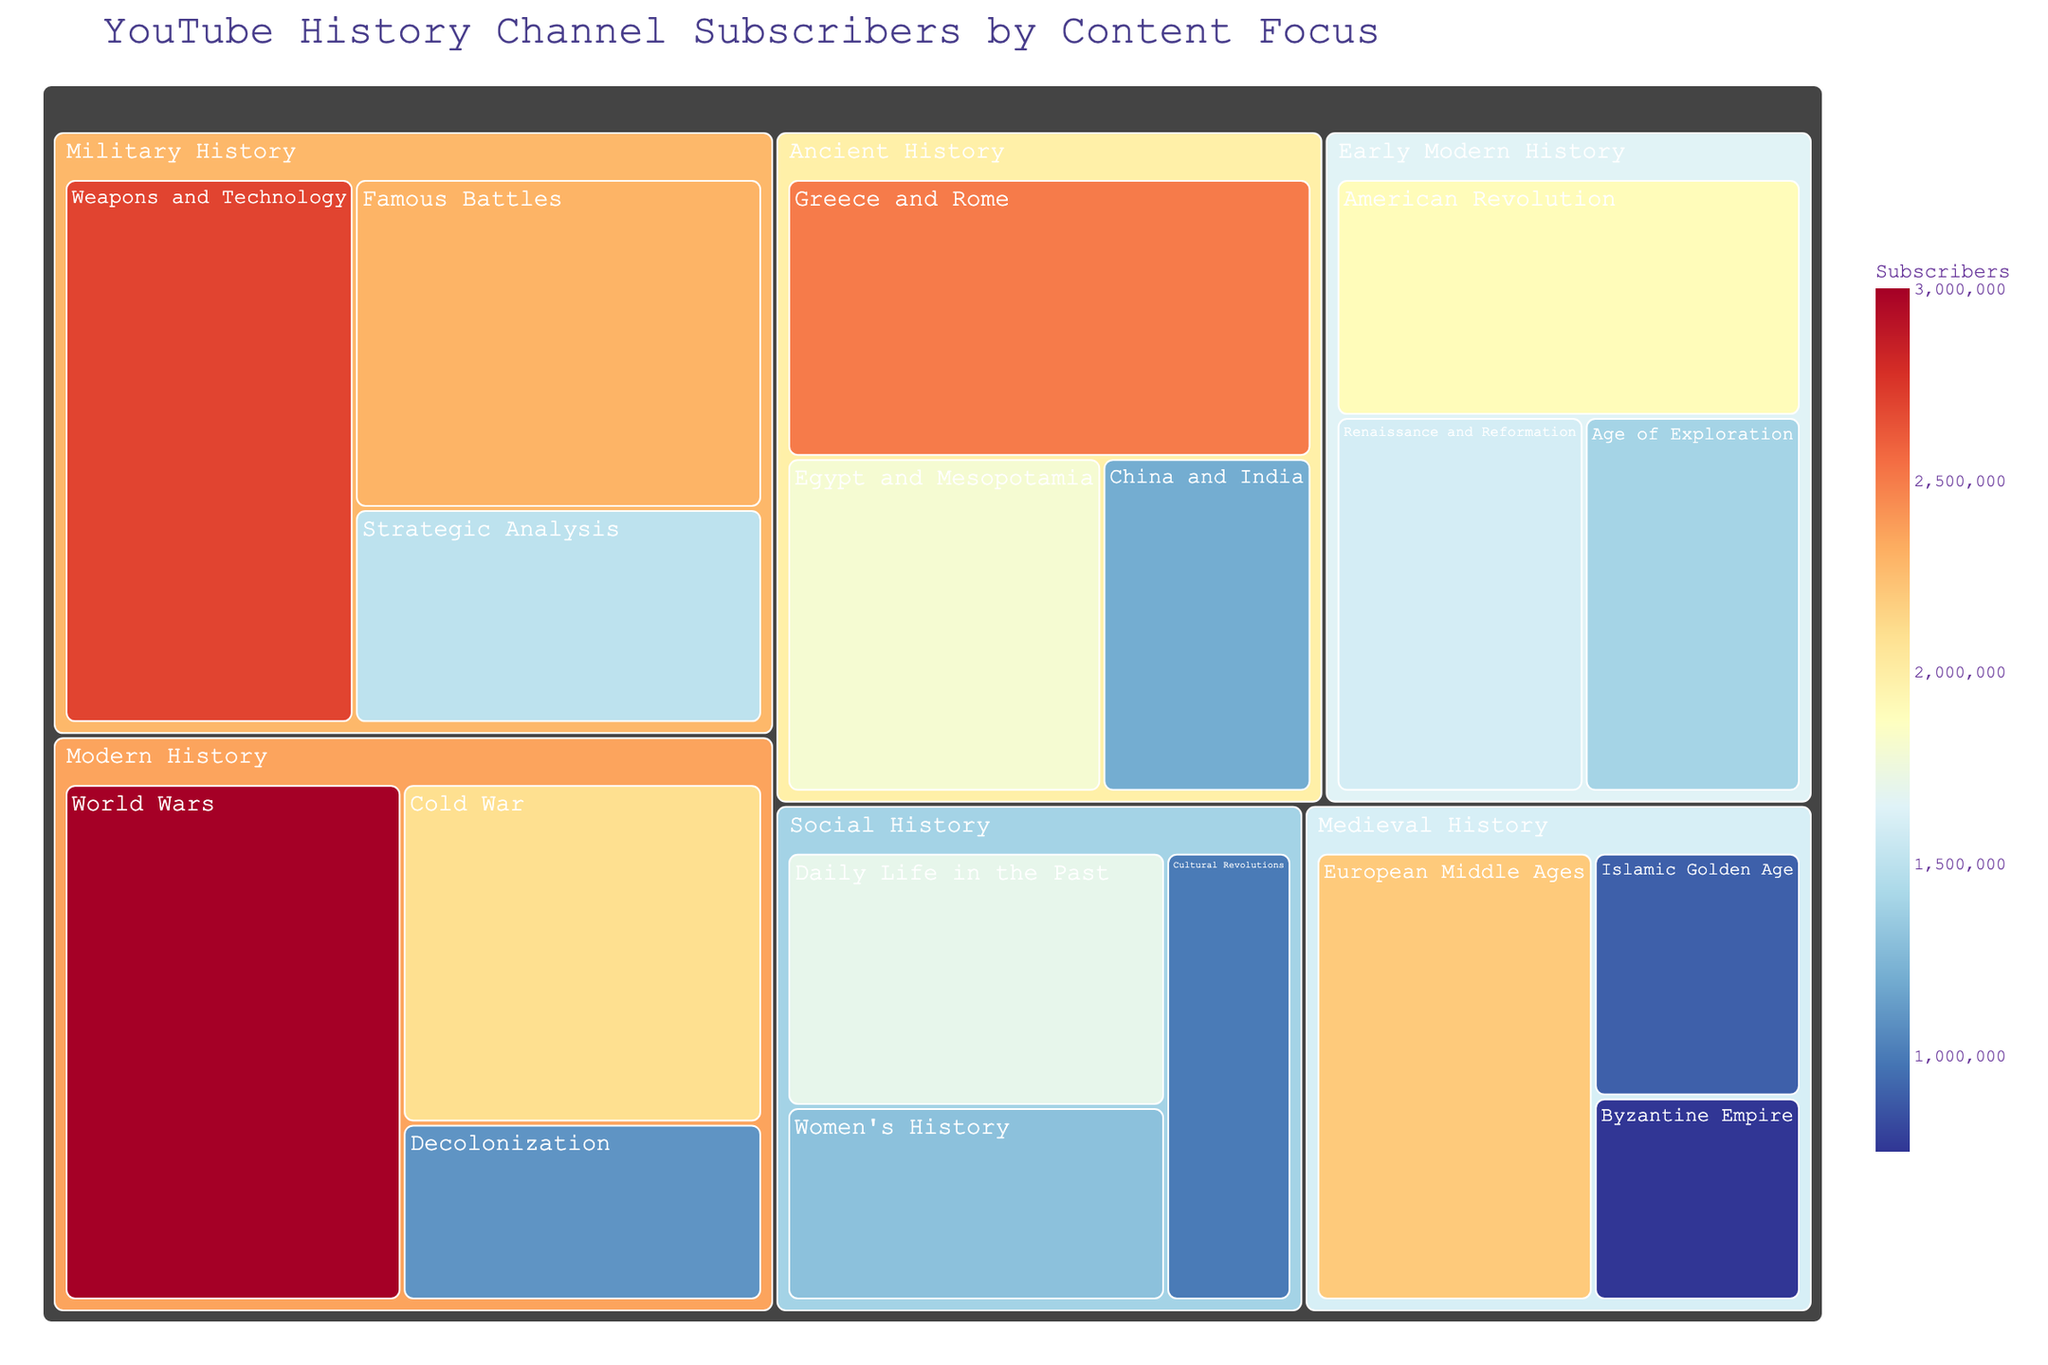What's the title of the figure? The title is displayed at the top of the figure.
Answer: YouTube History Channel Subscribers by Content Focus Which subcategory has the highest number of subscribers? Look for the section in the treemap with the largest area or the highest value in the subscriber count.
Answer: World Wars What is the total number of subscribers for the Ancient History category? Sum the subscriber counts for all subcategories under Ancient History: 2,500,000 + 1,800,000 + 1,200,000 = 5,500,000.
Answer: 5,500,000 How many more subscribers does Weapons and Technology have compared to Strategic Analysis? Subtract the subscribers of Strategic Analysis from Weapons and Technology: 2,700,000 - 1,500,000 = 1,200,000.
Answer: 1,200,000 Which category has the smallest subcategory in terms of subscribers, and what is its value? Identify the subcategory with the smallest value and check to which category it belongs.
Answer: Social History, Cultural Revolutions, 1,000,000 What is the combined subscriber count for Medieval History and Modern History categories? Sum the subscriber counts for all subcategories under both categories: (2,200,000 + 900,000 + 750,000) + (3,000,000 + 2,100,000 + 1,100,000) = 8,050,000.
Answer: 8,050,000 Which subcategories have more than 2,000,000 subscribers? Look for subcategories with a count above 2,000,000 in the treemap.
Answer: Greece and Rome, European Middle Ages, World Wars, Weapons and Technology, Famous Battles Which categories contain subcategories with subscriber counts under 1,500,000? Identify categories whose subcategories have counts less than 1,500,000 by inspecting the values in the treemap.
Answer: Ancient History, Medieval History, Early Modern History, Modern History, Military History, Social History Which Modern History subcategory has fewer subscribers than Cold War? Compare the other subcategories in Modern History to the Cold War count: World Wars (greater) and Decolonization (less).
Answer: Decolonization What is the average number of subscribers for subcategories in the Early Modern History category? Calculate the average by adding subscriber counts and dividing by the number of subcategories: (1,600,000 + 1,400,000 + 1,900,000) / 3 = 1,633,333.
Answer: 1,633,333 